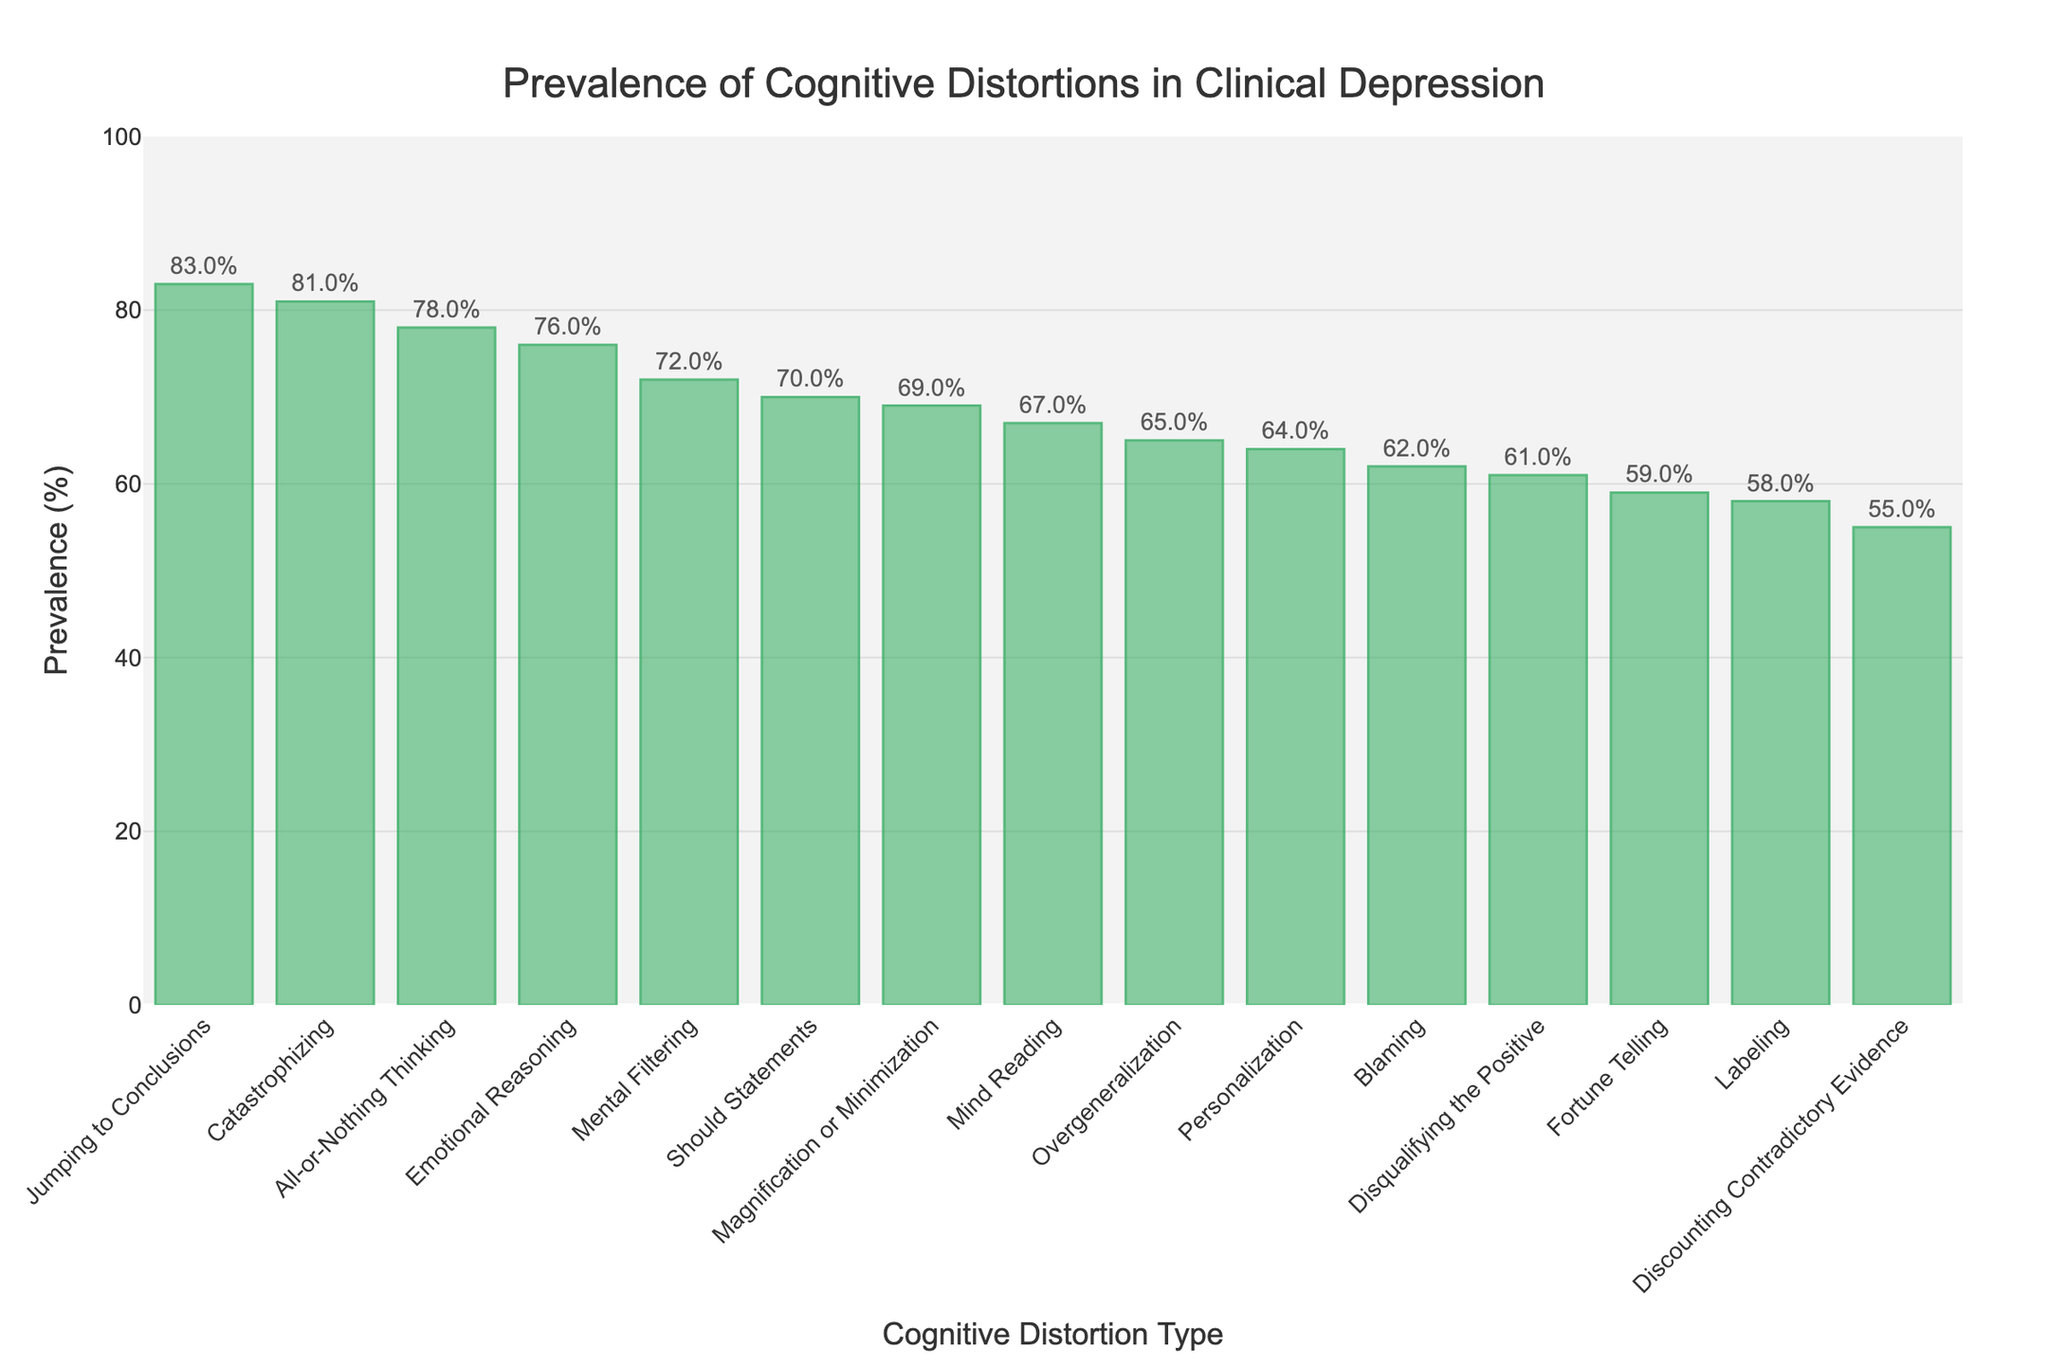Which cognitive distortion type has the highest prevalence? Identify the tallest bar in the bar chart. The bar representing "Jumping to Conclusions" is the tallest.
Answer: Jumping to Conclusions What is the difference in prevalence between "Jumping to Conclusions" and "Catastrophizing"? Find the bars for "Jumping to Conclusions" and "Catastrophizing". Their heights correspond to 83% and 81%, respectively. Subtract the smaller value from the larger one (83 - 81).
Answer: 2% Which cognitive distortion type has the lowest prevalence? Identify the shortest bar in the bar chart. The bar representing "Discounting Contradictory Evidence" is the shortest.
Answer: Discounting Contradictory Evidence What is the average prevalence of "All-or-Nothing Thinking," "Overgeneralization," and "Mental Filtering"? Identify the bars for these three types and record their heights (78%, 65%, and 72%). Sum these values (78 + 65 + 72 = 215) and divide by 3.
Answer: 71.7% How many cognitive distortion types have a prevalence above 70%? Count the bars that exceed the 70% mark. The bars for "All-or-Nothing Thinking" (78%), "Mental Filtering" (72%), "Jumping to Conclusions" (83%), "Emotional Reasoning" (76%), and "Catastrophizing" (81%) all exceed 70%. There are 5 bars.
Answer: 5 Which cognitive distortion type has a prevalence closest to the median value of all distortions? List all prevalence values: 78, 65, 72, 61, 83, 69, 76, 70, 58, 64, 81, 67, 59, 55, 62. Arrange in ascending order: 55, 58, 59, 61, 62, 64, 65, 67, 69, 70, 72, 76, 78, 81, 83. The median value is the 8th value: 67. The cognitive distortion type with this value is "Mind Reading".
Answer: Mind Reading What is the sum of prevalences of "Labeling" and "Blaming"? Identify the bars for "Labeling" and "Blaming". Their heights correspond to 58% and 62%, respectively. Add these values together (58 + 62).
Answer: 120% Compare "Should Statements" and "Fortune Telling": which one has a higher prevalence and by how much? Find the bars for "Should Statements" (70%) and "Fortune Telling" (59%). Subtract 59 from 70 (70 - 59).
Answer: "Should Statements", 11% How does the sum of the prevalences of the top 3 most common distortions compare to the sum of the bottom 3? Identify and sum the prevalences of the top 3 ("Jumping to Conclusions" 83%, "Catastrophizing" 81%, "All-or-Nothing Thinking" 78%) which equals 83 + 81 + 78 = 242. Sum the prevalences of the bottom 3 ("Discounting Contradictory Evidence" 55%, "Labeling" 58%, "Fortune Telling" 59%) which equals 55 + 58 + 59 = 172. Compare the sums (top 3 is 242, bottom 3 is 172).
Answer: 70 more Are there more cognitive distortion types with prevalence above 65% or below 65%? Count the bars above and below the 65% mark. There are 9 bars above 65% (78, 72, 83, 76, 70, 69, 81, 67) and 6 bars below 65% (65, 61, 58, 64, 59, 55).
Answer: Above, which have 9 